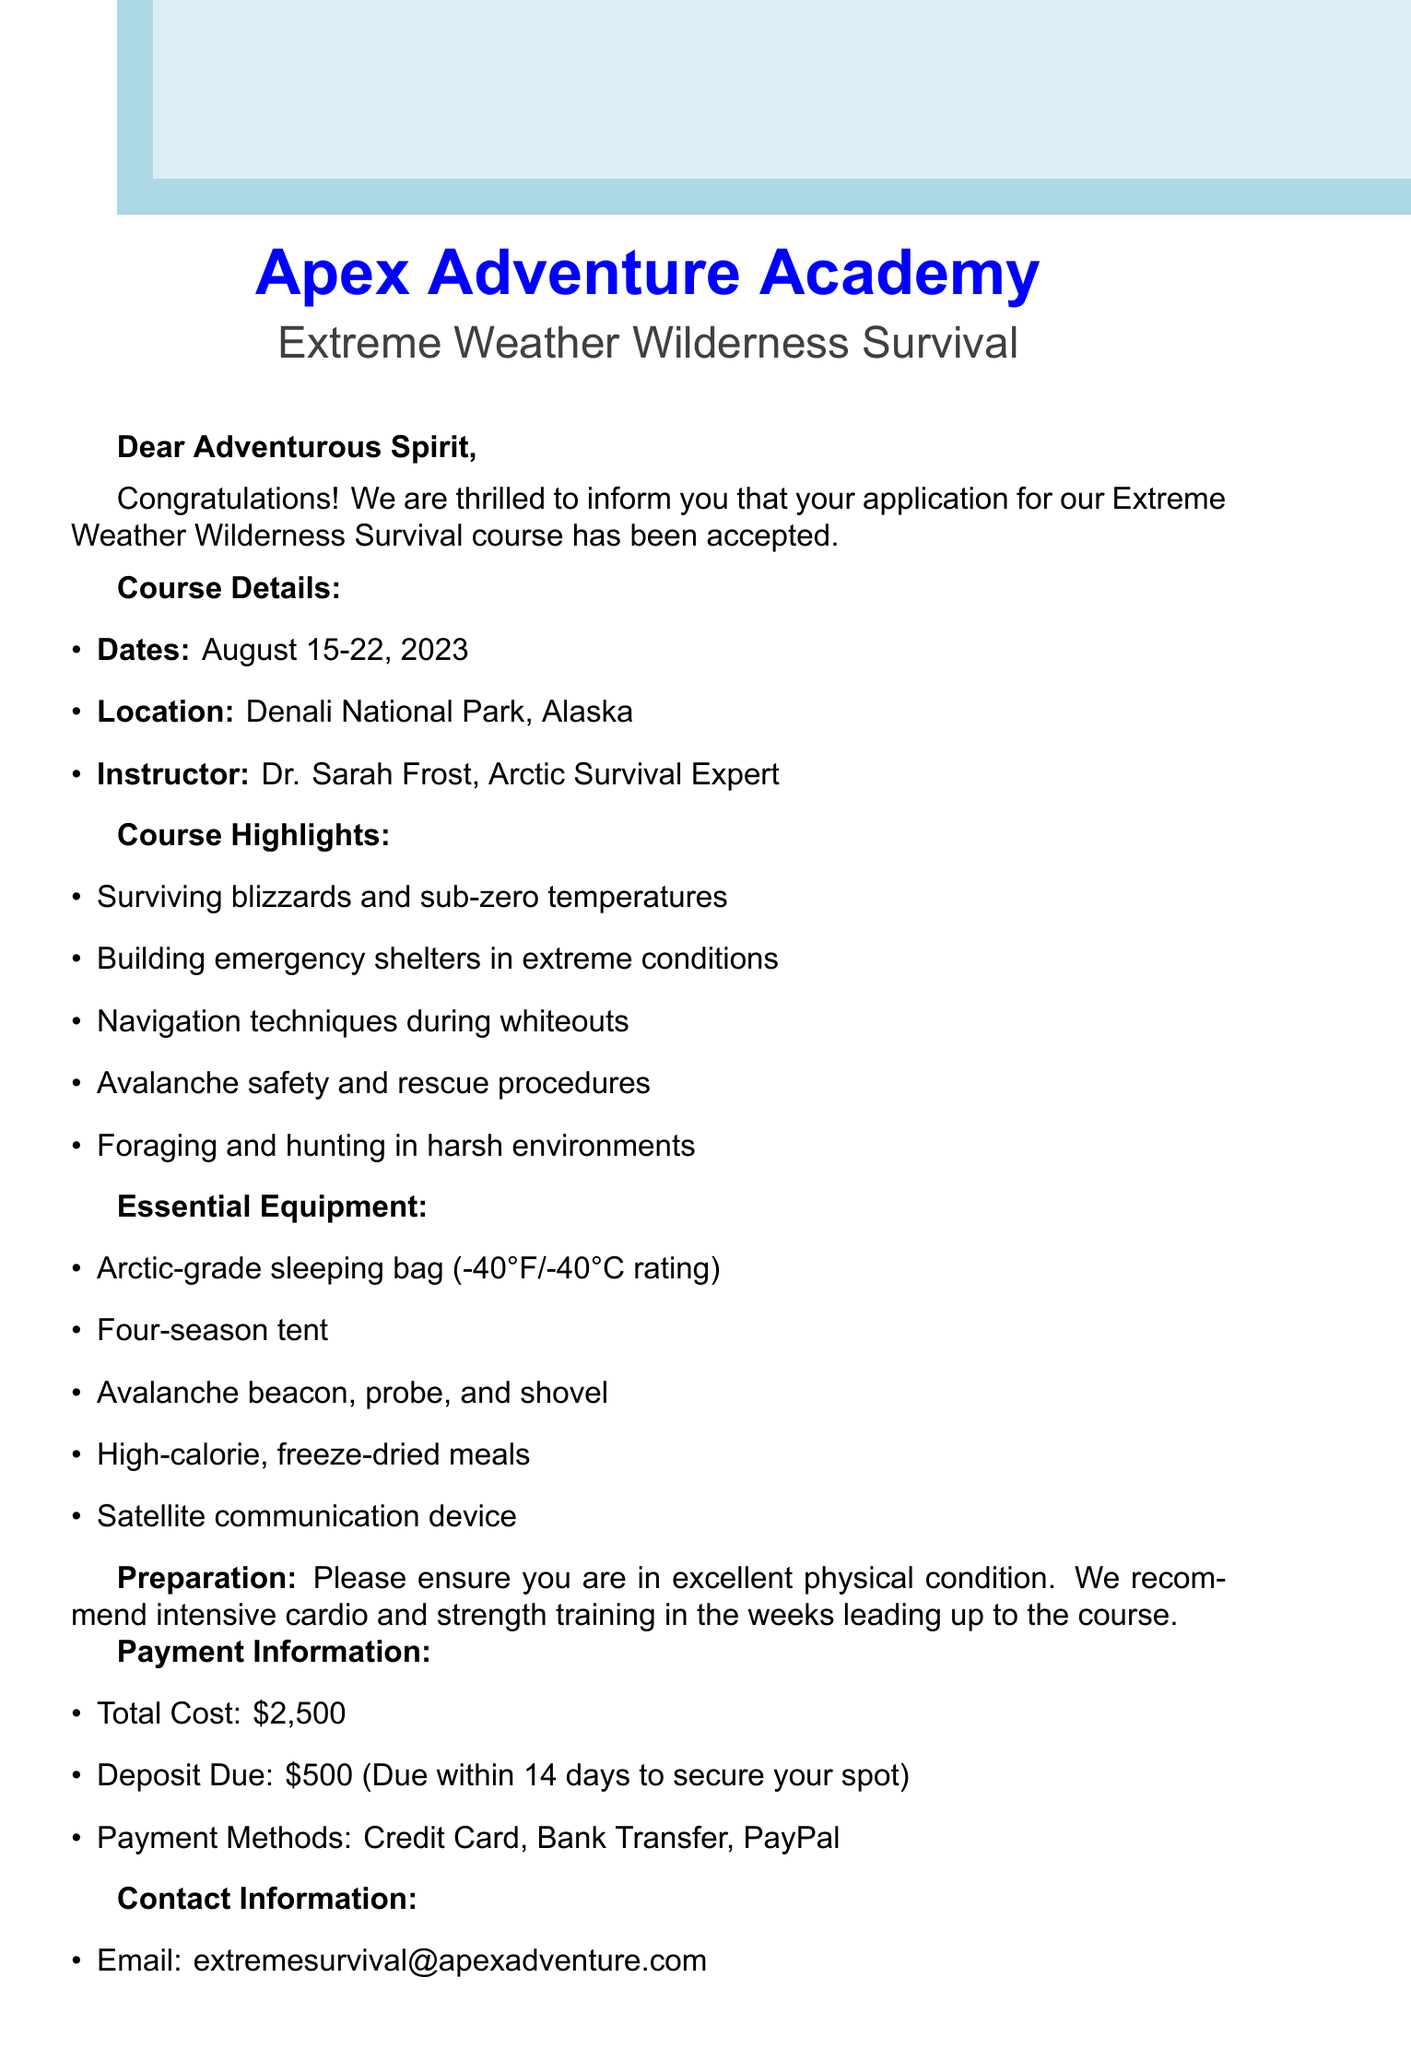What are the course dates? The course dates are specified in the document as August 15-22, 2023.
Answer: August 15-22, 2023 Who is the instructor? The instructor for the course is mentioned in the document as Dr. Sarah Frost, an Arctic Survival Expert.
Answer: Dr. Sarah Frost What is the location of the course? The document highlights that the course will take place at Denali National Park, Alaska.
Answer: Denali National Park, Alaska What is the total cost of the course? The total cost for the course is given in the payment information section as $2,500.
Answer: $2,500 Which equipment is required for the course? The essential equipment needed is outlined in the equipment list in the document.
Answer: Arctic-grade sleeping bag, Four-season tent, Avalanche beacon, probe, and shovel, High-calorie, freeze-dried meals, Satellite communication device How much is the deposit due? The document states that the deposit due to secure a spot is $500, which should be paid within 14 days.
Answer: $500 What kind of training is recommended before the course? The document advises participants to engage in intensive cardio and strength training leading up to the course.
Answer: Intensive cardio and strength training What is the purpose of this document? The document serves as a notice of acceptance for a wilderness survival course, informing the participant about course details and requirements.
Answer: Notice of acceptance What type of weather conditions will be covered in the course? The document highlights that the course will focus on surviving blizzards and sub-zero temperatures.
Answer: Blizzards and sub-zero temperatures 